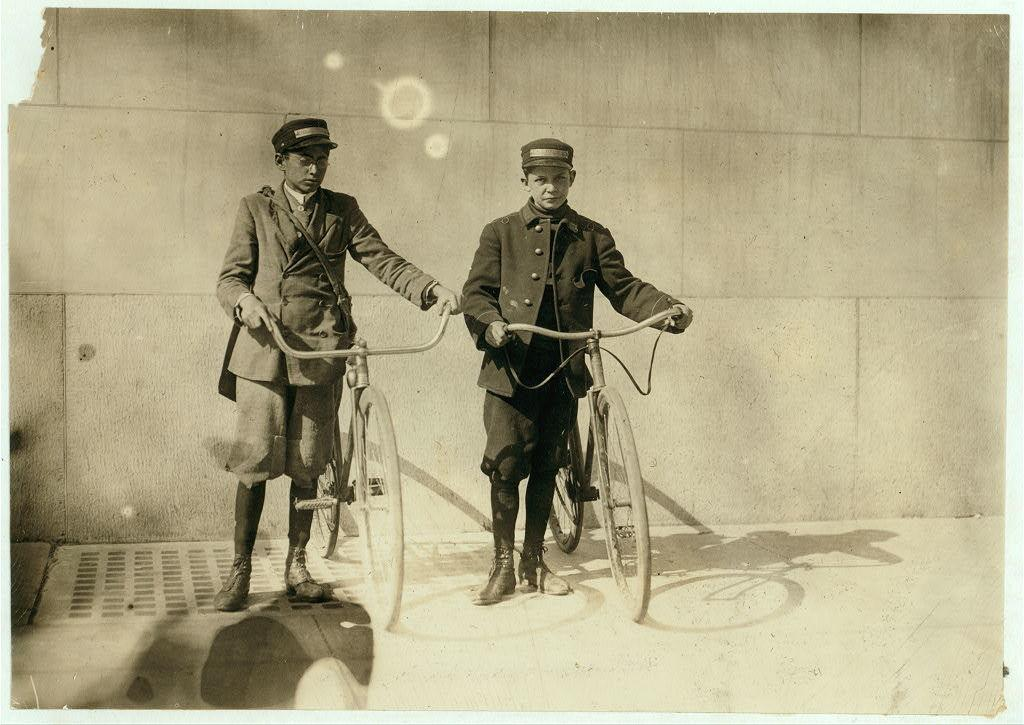How many people are in the image? There are two persons in the image. What are the persons wearing? The persons are wearing jackets. What are the persons doing in the image? The persons are standing and holding bicycles. What can be seen in the background of the image? There is an object in the background that appears to be a wall. What grade are the persons in the image in? There is no information about the persons' grade in the image. 